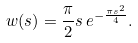<formula> <loc_0><loc_0><loc_500><loc_500>w ( s ) = \frac { \pi } { 2 } s \, e ^ { - \frac { \pi s ^ { 2 } } { 4 } } .</formula> 